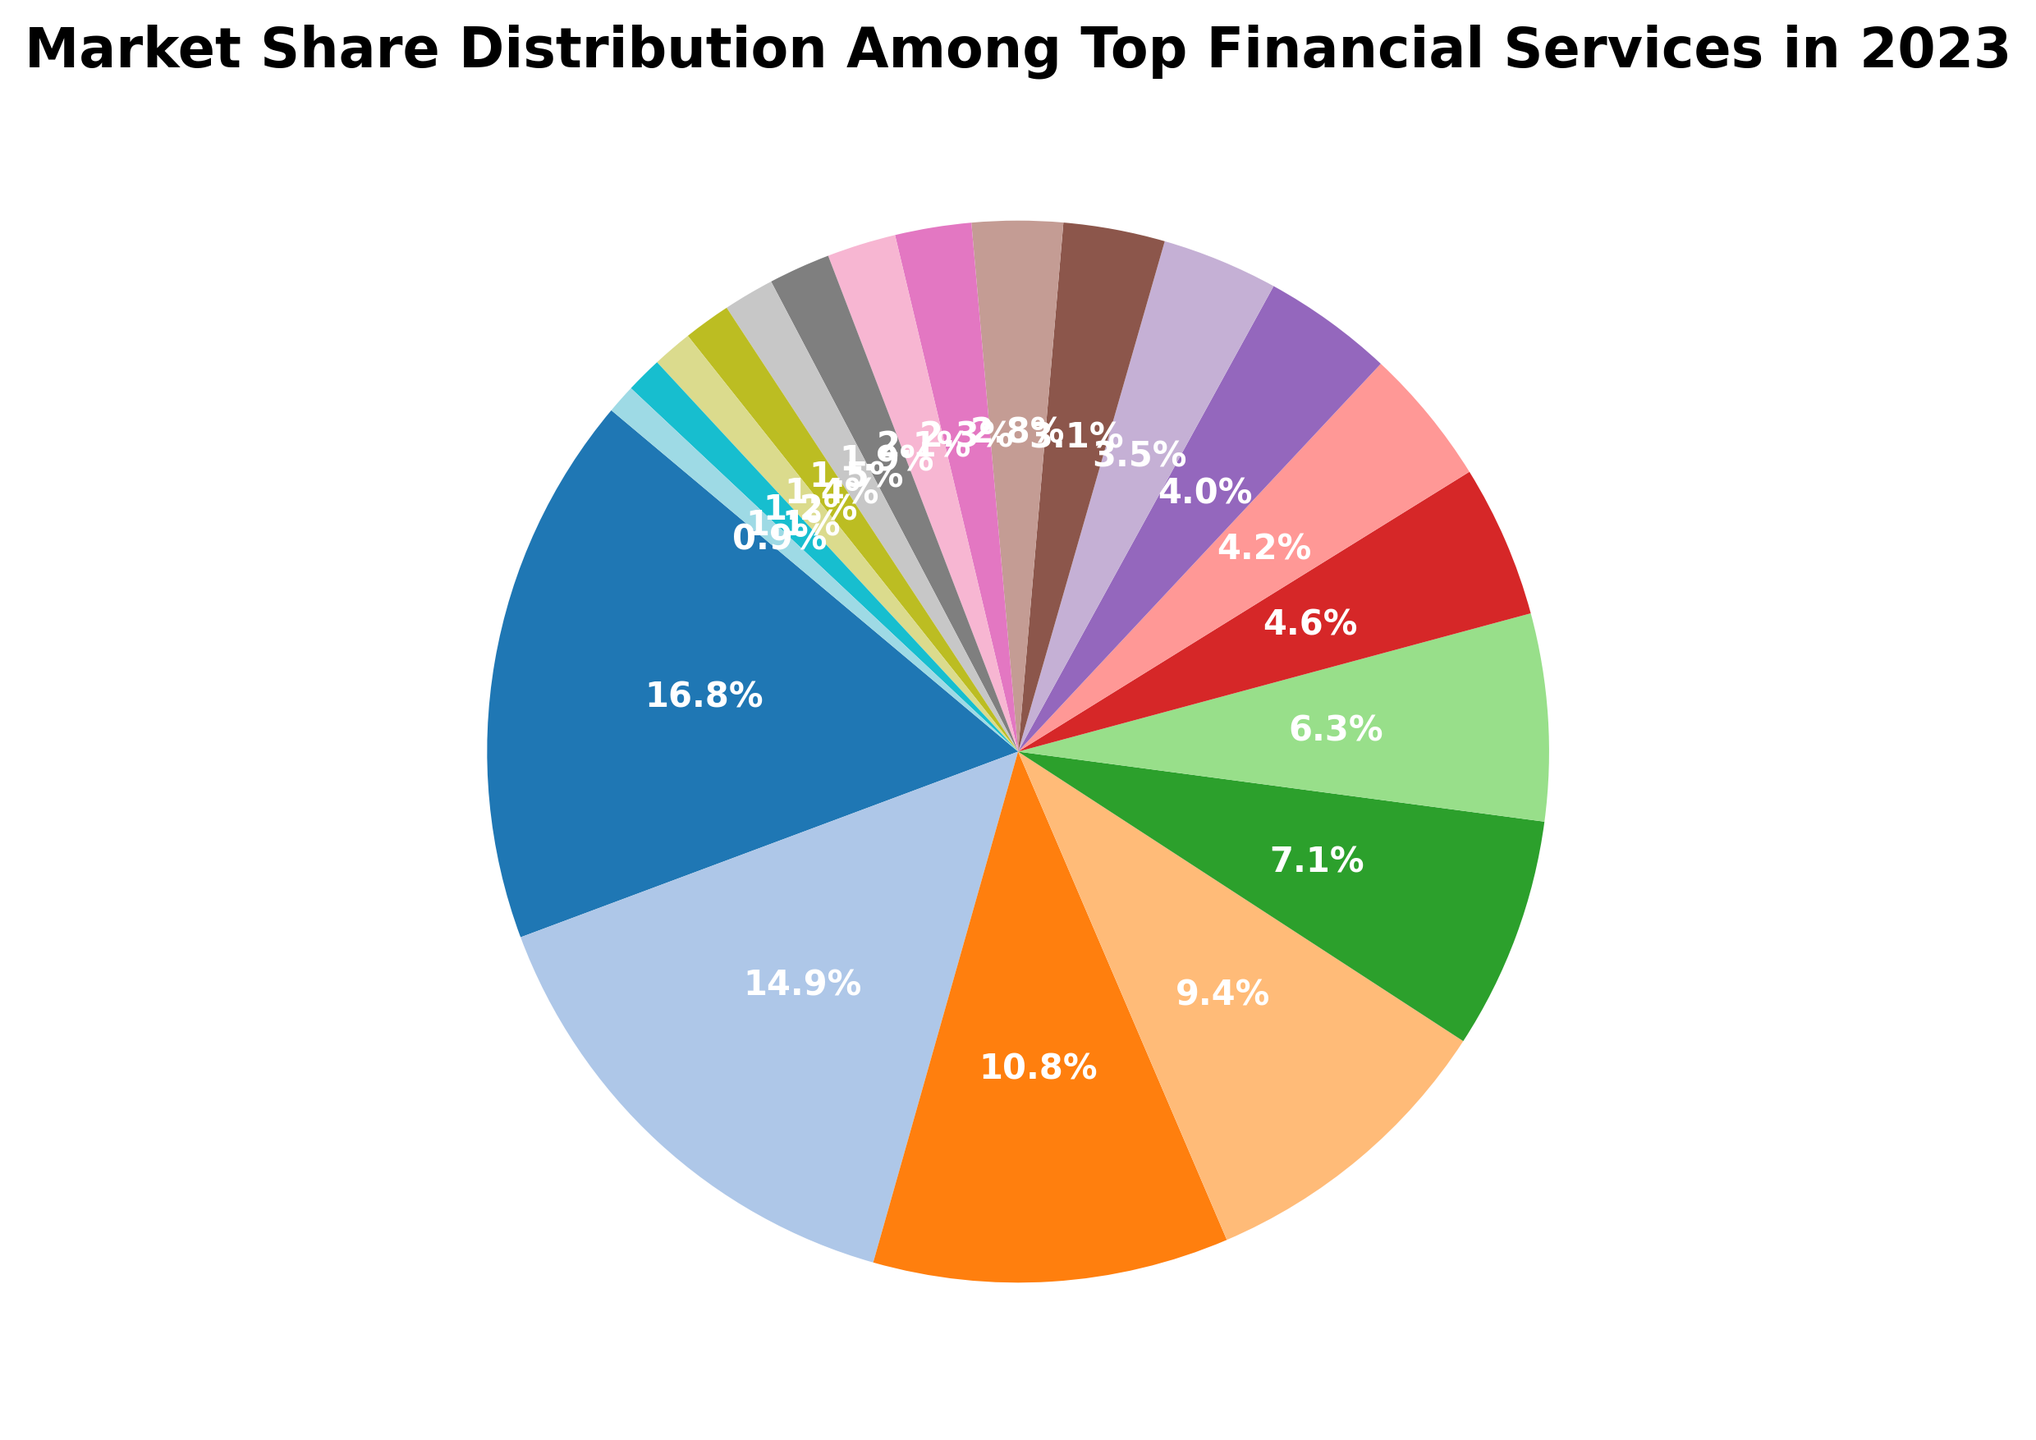What is the market share of JPMorgan Chase? To find JPMorgan Chase's market share, look for the section of the pie chart labeled "JPMorgan Chase" and read the associated percentage.
Answer: 15.2% Which company has the smallest market share? Identify the smallest slice of the pie chart and read its label. KeyCorp, with the smallest slice, has a market share of 0.8%.
Answer: KeyCorp What is the total market share of JPMorgan Chase and Bank of America combined? Sum the market shares of JPMorgan Chase (15.2%) and Bank of America (13.5%). This is 15.2% + 13.5% = 28.7%.
Answer: 28.7% Is the market share of Wells Fargo greater than that of Citigroup? Compare the pie slices labeled "Wells Fargo" (9.8%) and "Citigroup" (8.5%). Since 9.8% is greater than 8.5%, Wells Fargo has a larger market share.
Answer: Yes What is the average market share of Bank of America, Citigroup, and Goldman Sachs? Sum the market shares of Bank of America (13.5%), Citigroup (8.5%), and Goldman Sachs (6.4%) and divide by 3. The sum is 13.5% + 8.5% + 6.4% = 28.4%. The average is 28.4% / 3 = 9.47%.
Answer: 9.47% Which companies have a market share greater than 5% but less than 10%? Look at the slices of the pie chart and identify those with percentages between 5% and 10%. Wells Fargo (9.8%), Citigroup (8.5%), and Goldman Sachs (6.4%) fit this criterion.
Answer: Wells Fargo, Citigroup, Goldman Sachs What is the approximate difference in market share between Morgan Stanley and U.S. Bancorp? Subtract U.S. Bancorp's market share (4.2%) from Morgan Stanley's market share (5.7%). The difference is 5.7% - 4.2% = 1.5%.
Answer: 1.5% Who has a larger market share, PNC Financial Services or Charles Schwab? Compare the pie slices labeled "PNC Financial Services" (3.8%) and "Charles Schwab" (3.6%). Since 3.8% is larger than 3.6%, PNC Financial Services has a larger market share.
Answer: PNC Financial Services What market share is shared by companies with less than 2% market share each? Sum the market shares of companies listed with less than 2% individually: TD Bank (2.1%), Capital One (1.9%), BB&T (1.7%), SunTrust Banks (1.4%), HSBC USA (1.3%), Ally Financial (1.1%), Northern Trust (1.0%), and KeyCorp (0.8%). The sum is 2.1% + 1.9% + 1.7% + 1.4% + 1.3% + 1.1% + 1.0% + 0.8% = 11.3%.
Answer: 11.3% What is the color of the slice representing Goldman Sachs? Observe the color of the pie chart slice labeled "Goldman Sachs." It is visually colored according to the palette used (a shade within the tab20 colormap).
Answer: Light green 